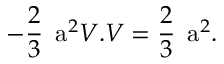<formula> <loc_0><loc_0><loc_500><loc_500>- \frac { 2 } { 3 } a ^ { 2 } V . V = \frac { 2 } { 3 } a ^ { 2 } .</formula> 